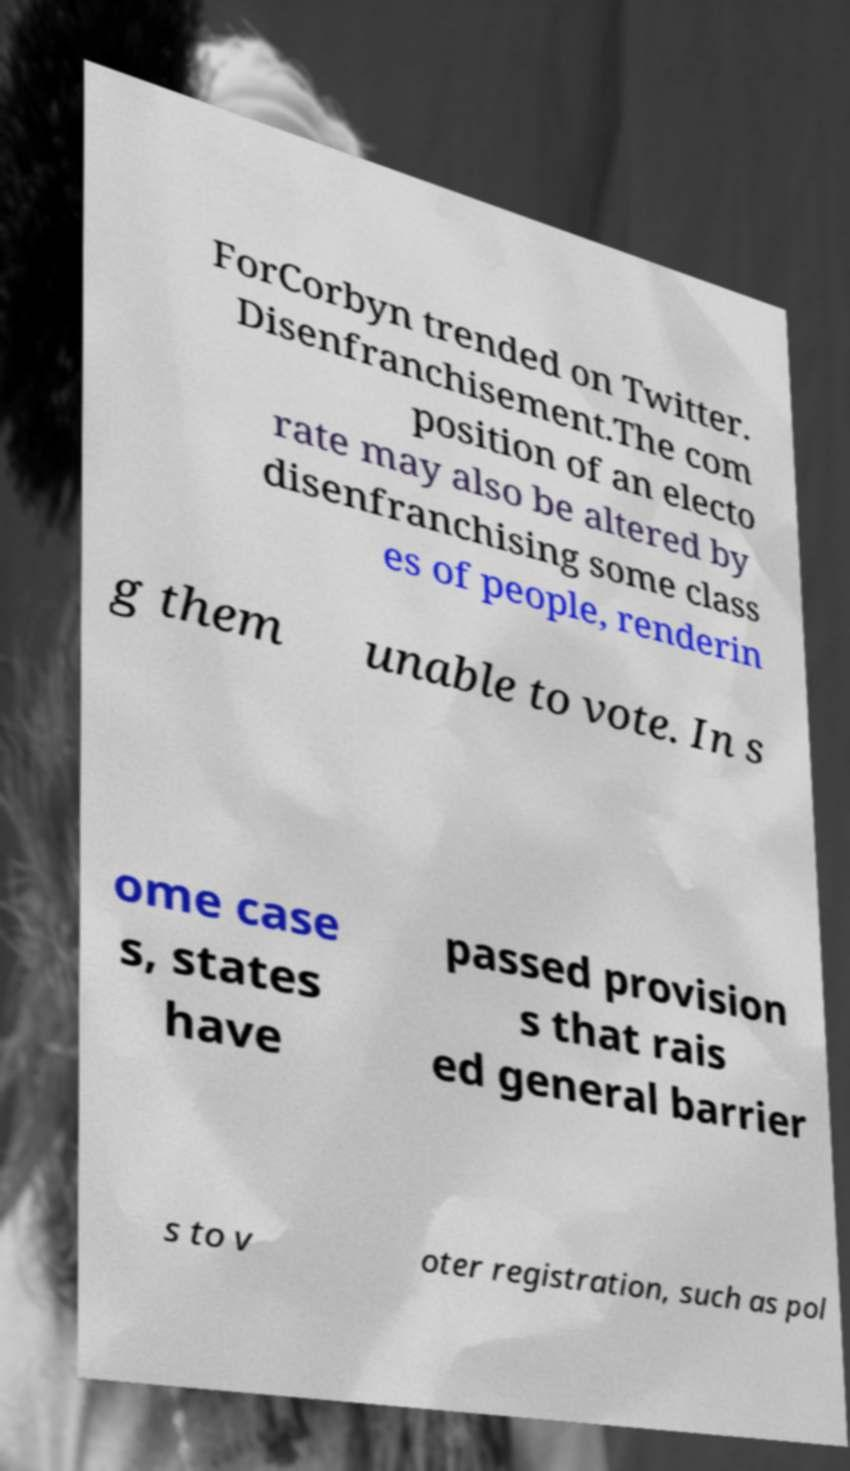For documentation purposes, I need the text within this image transcribed. Could you provide that? ForCorbyn trended on Twitter. Disenfranchisement.The com position of an electo rate may also be altered by disenfranchising some class es of people, renderin g them unable to vote. In s ome case s, states have passed provision s that rais ed general barrier s to v oter registration, such as pol 